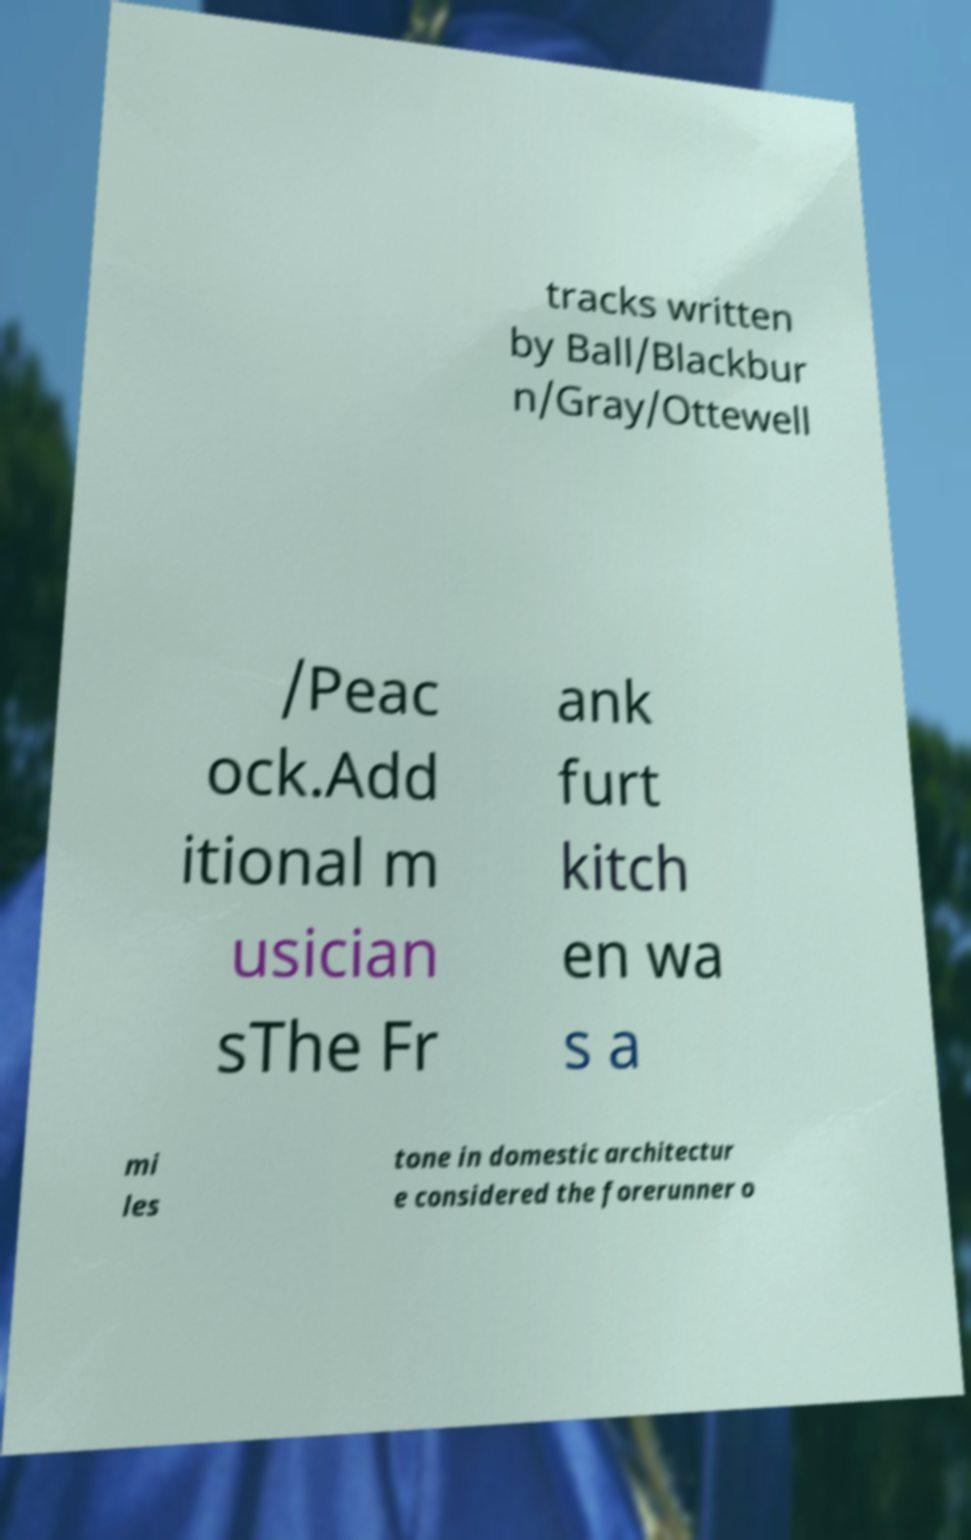Please read and relay the text visible in this image. What does it say? tracks written by Ball/Blackbur n/Gray/Ottewell /Peac ock.Add itional m usician sThe Fr ank furt kitch en wa s a mi les tone in domestic architectur e considered the forerunner o 